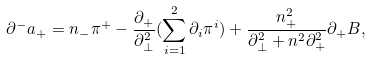<formula> <loc_0><loc_0><loc_500><loc_500>{ \partial } ^ { - } a _ { + } = n _ { - } { \pi } ^ { + } - \frac { { \partial } _ { + } } { { \partial } _ { \bot } ^ { 2 } } ( \sum _ { i = 1 } ^ { 2 } { \partial } _ { i } { \pi } ^ { i } ) + \frac { n _ { + } ^ { 2 } } { { \partial } _ { \bot } ^ { 2 } + n ^ { 2 } { \partial } _ { + } ^ { 2 } } { \partial } _ { + } B ,</formula> 